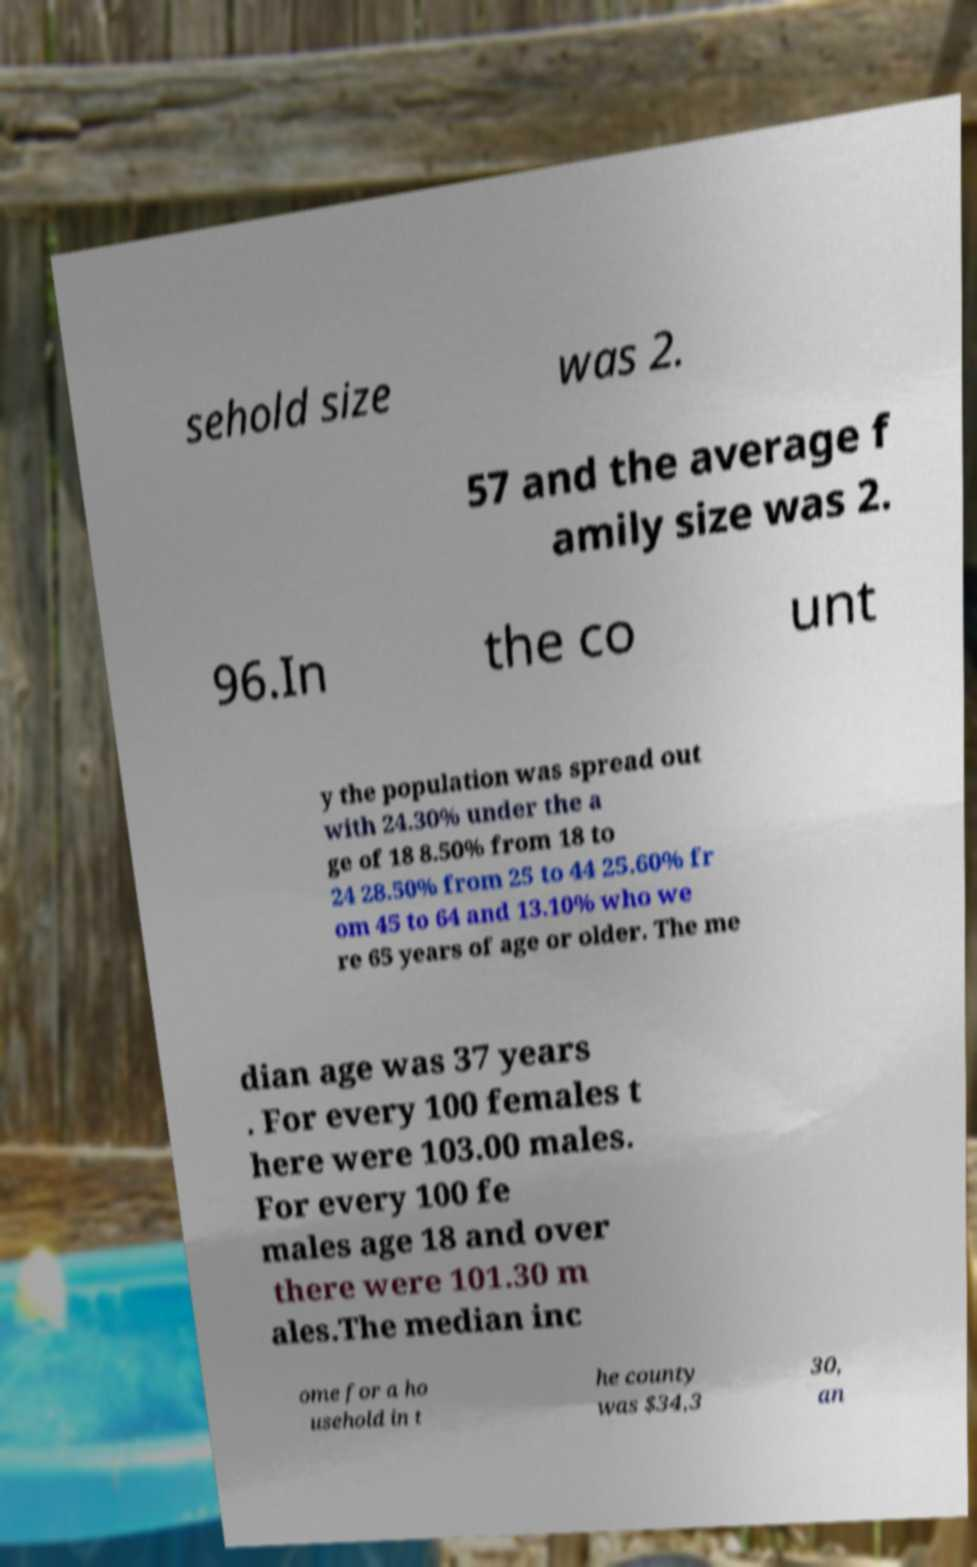For documentation purposes, I need the text within this image transcribed. Could you provide that? sehold size was 2. 57 and the average f amily size was 2. 96.In the co unt y the population was spread out with 24.30% under the a ge of 18 8.50% from 18 to 24 28.50% from 25 to 44 25.60% fr om 45 to 64 and 13.10% who we re 65 years of age or older. The me dian age was 37 years . For every 100 females t here were 103.00 males. For every 100 fe males age 18 and over there were 101.30 m ales.The median inc ome for a ho usehold in t he county was $34,3 30, an 